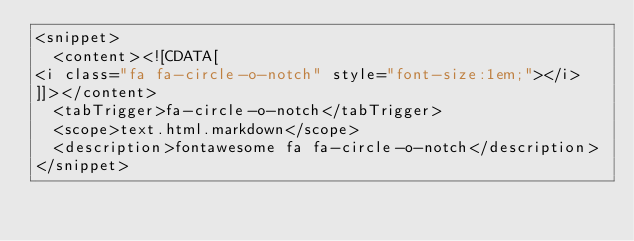<code> <loc_0><loc_0><loc_500><loc_500><_XML_><snippet>
  <content><![CDATA[
<i class="fa fa-circle-o-notch" style="font-size:1em;"></i>
]]></content>
  <tabTrigger>fa-circle-o-notch</tabTrigger>
  <scope>text.html.markdown</scope>
  <description>fontawesome fa fa-circle-o-notch</description>
</snippet>
</code> 